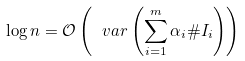<formula> <loc_0><loc_0><loc_500><loc_500>\log n = \mathcal { O } \left ( \ v a r \left ( \sum _ { i = 1 } ^ { m } \alpha _ { i } \# I _ { i } \right ) \right )</formula> 